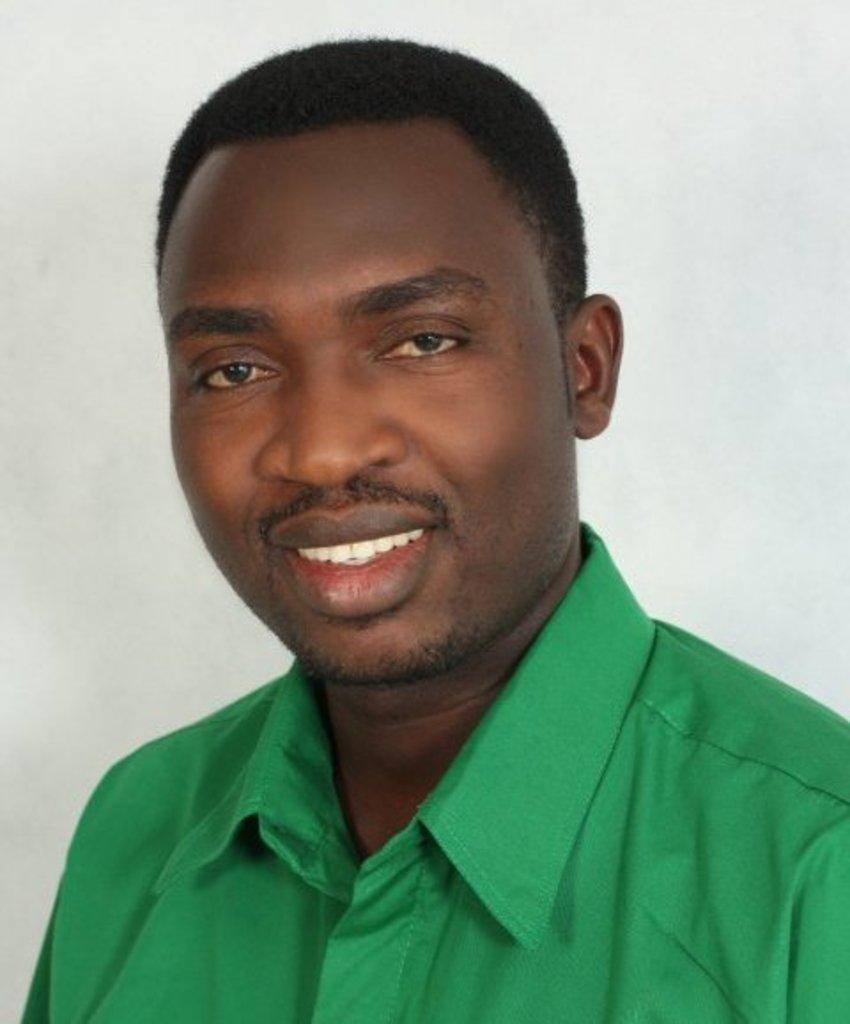What is the main subject of the image? There is a man in the image. What is the man wearing in the image? The man is wearing a green shirt. What expression does the man have in the image? The man is smiling. What type of note is the man holding in the image? There is no note present in the image; the man is not holding anything. How many rings can be seen on the man's fingers in the image? There are no rings visible on the man's fingers in the image. 